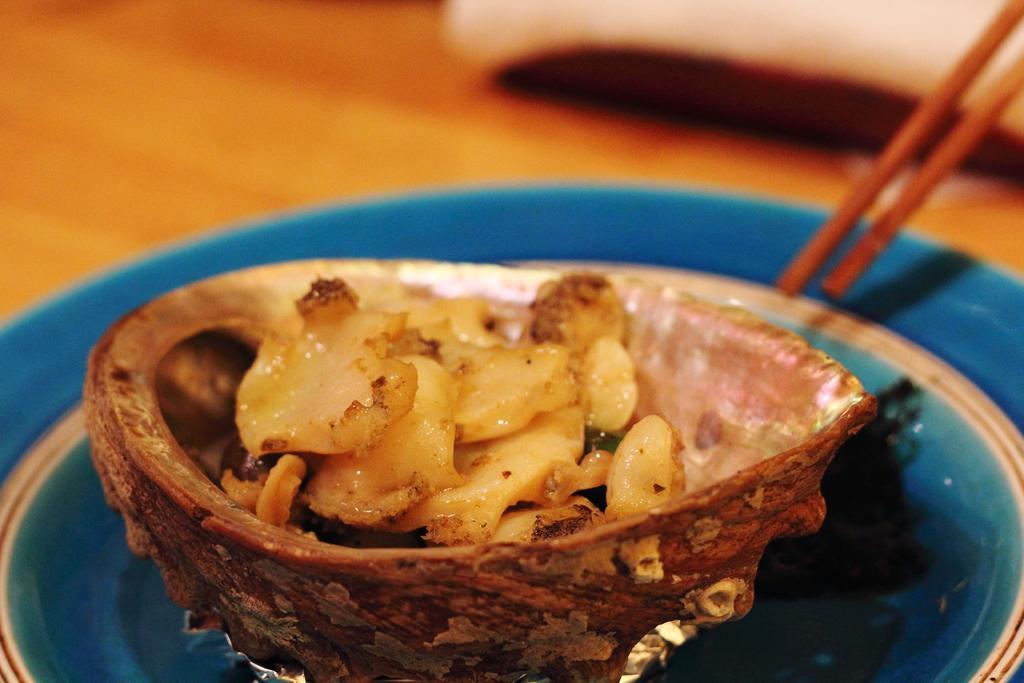In one or two sentences, can you explain what this image depicts? This is a table. It is plate. It is a wooden bowl and there is food item in wooden bowl and these are wooden sticks 